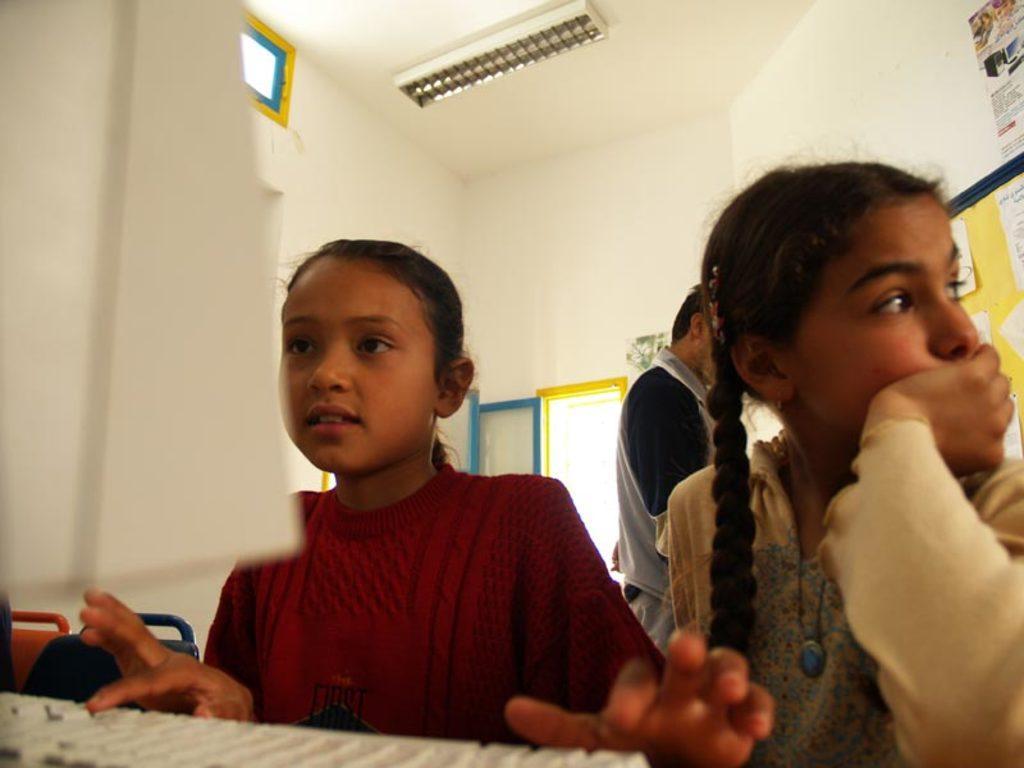Please provide a concise description of this image. In this image there are two girls in the middle. The girl on the left side is typing the keys which are on the keyboard. At the top there is light. In the background there are windows. On the right side there is a board on which there are papers. In the middle there is a man. 